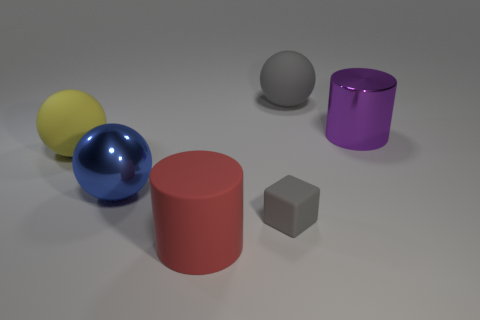Subtract 1 spheres. How many spheres are left? 2 Subtract all large blue balls. How many balls are left? 2 Add 2 tiny red cubes. How many objects exist? 8 Subtract all cylinders. How many objects are left? 4 Add 2 tiny gray cubes. How many tiny gray cubes are left? 3 Add 3 big red metallic blocks. How many big red metallic blocks exist? 3 Subtract 0 purple blocks. How many objects are left? 6 Subtract all tiny brown metal things. Subtract all large matte things. How many objects are left? 3 